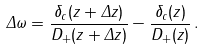<formula> <loc_0><loc_0><loc_500><loc_500>\Delta \omega = \frac { \delta _ { c } ( z + \Delta z ) } { D _ { + } ( z + \Delta z ) } - \frac { \delta _ { c } ( z ) } { D _ { + } ( z ) } \, .</formula> 